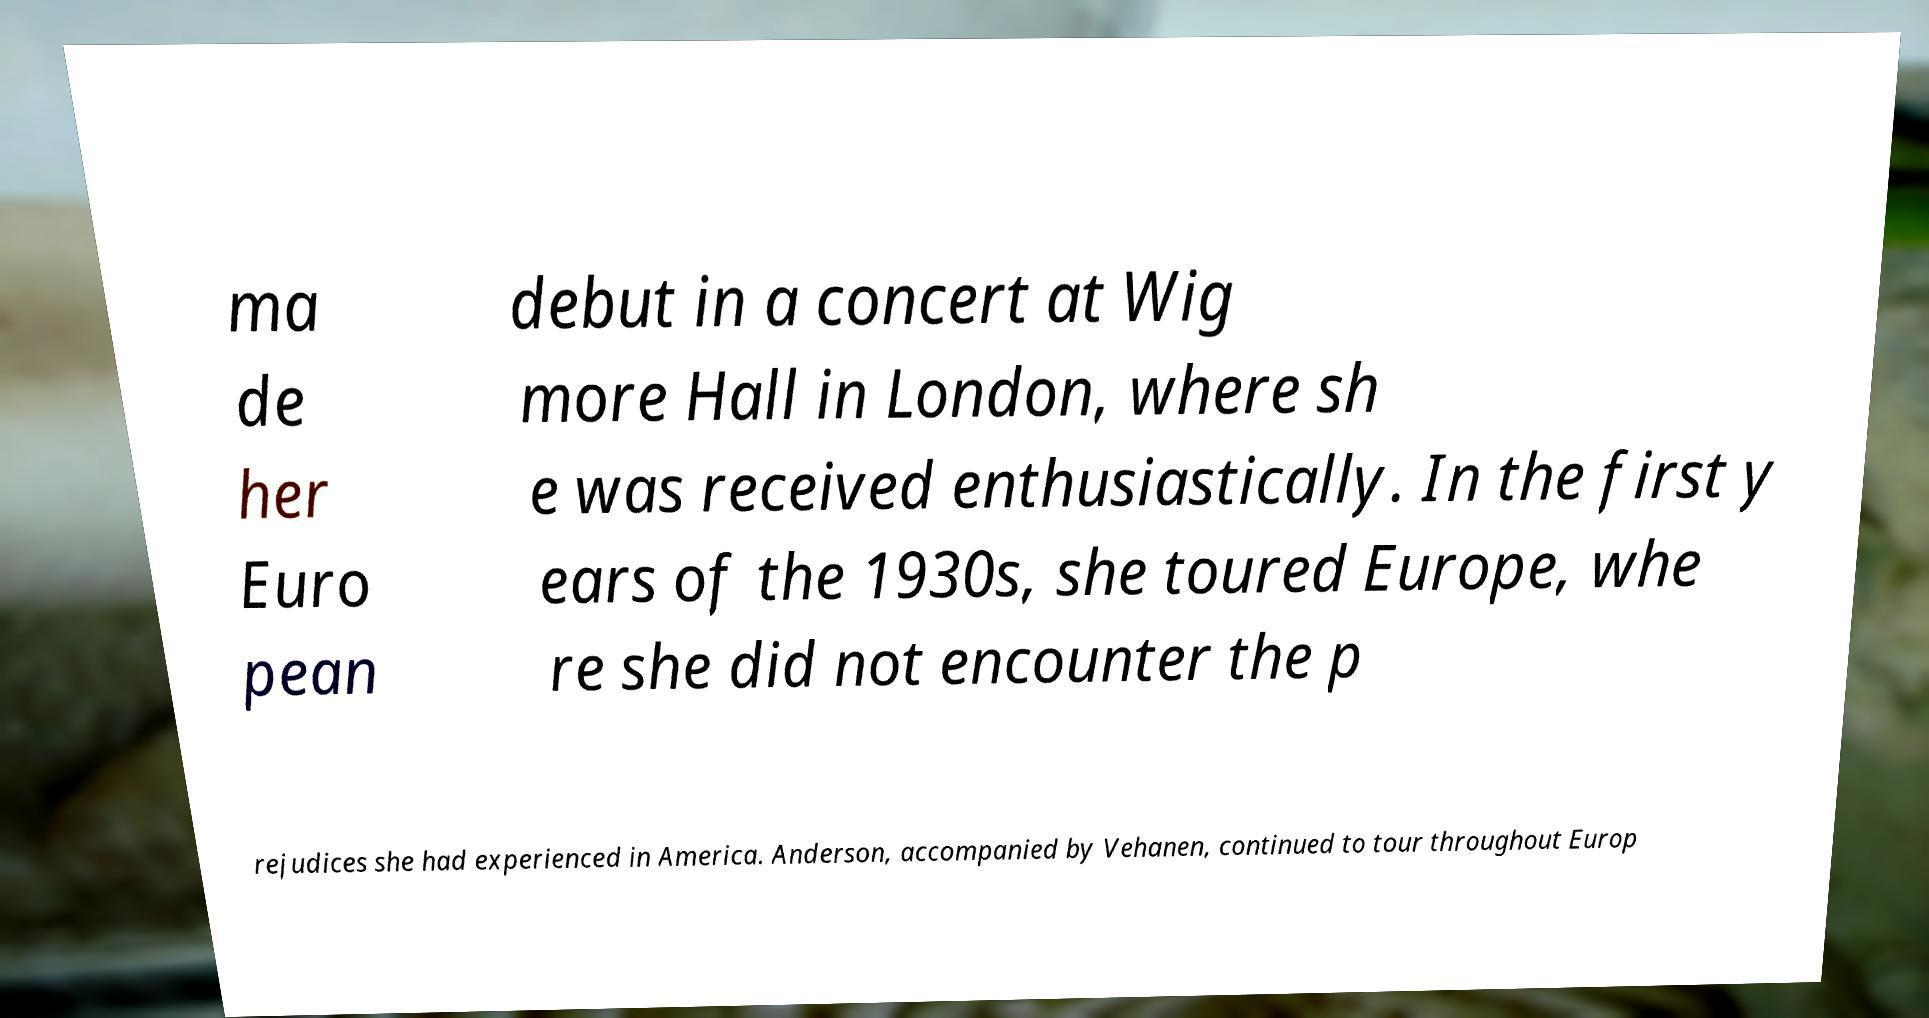Please identify and transcribe the text found in this image. ma de her Euro pean debut in a concert at Wig more Hall in London, where sh e was received enthusiastically. In the first y ears of the 1930s, she toured Europe, whe re she did not encounter the p rejudices she had experienced in America. Anderson, accompanied by Vehanen, continued to tour throughout Europ 